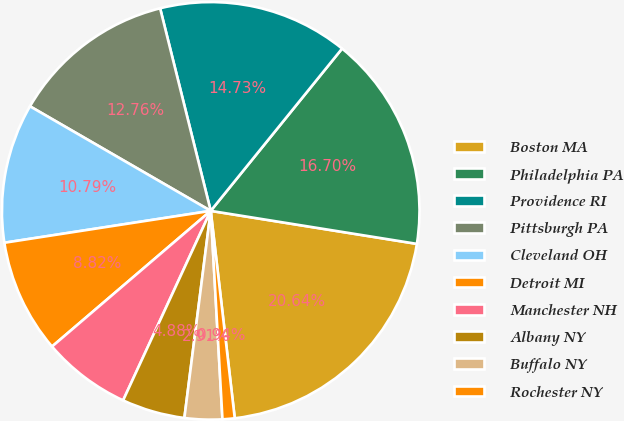<chart> <loc_0><loc_0><loc_500><loc_500><pie_chart><fcel>Boston MA<fcel>Philadelphia PA<fcel>Providence RI<fcel>Pittsburgh PA<fcel>Cleveland OH<fcel>Detroit MI<fcel>Manchester NH<fcel>Albany NY<fcel>Buffalo NY<fcel>Rochester NY<nl><fcel>20.64%<fcel>16.7%<fcel>14.73%<fcel>12.76%<fcel>10.79%<fcel>8.82%<fcel>6.85%<fcel>4.88%<fcel>2.91%<fcel>0.94%<nl></chart> 